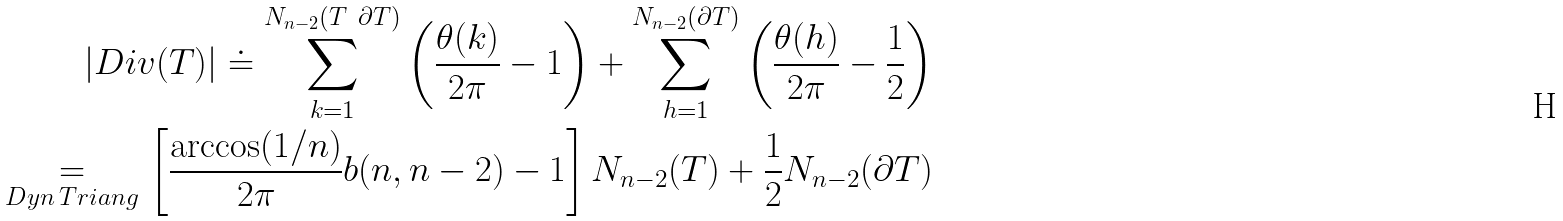Convert formula to latex. <formula><loc_0><loc_0><loc_500><loc_500>\left | D i v ( T ) \right | \doteq \sum _ { k = 1 } ^ { N _ { n - 2 } ( T \ \partial T ) } \left ( \frac { \theta ( k ) } { 2 \pi } - 1 \right ) + \sum _ { h = 1 } ^ { N _ { n - 2 } ( \partial T ) } \left ( \frac { \theta ( h ) } { 2 \pi } - \frac { 1 } { 2 } \right ) \\ \underset { D y n \, T r i a n g } { = } \left [ \frac { \arccos ( 1 / n ) } { 2 \pi } b ( n , n - 2 ) - 1 \right ] N _ { n - 2 } ( T ) + \frac { 1 } { 2 } N _ { n - 2 } ( \partial T )</formula> 